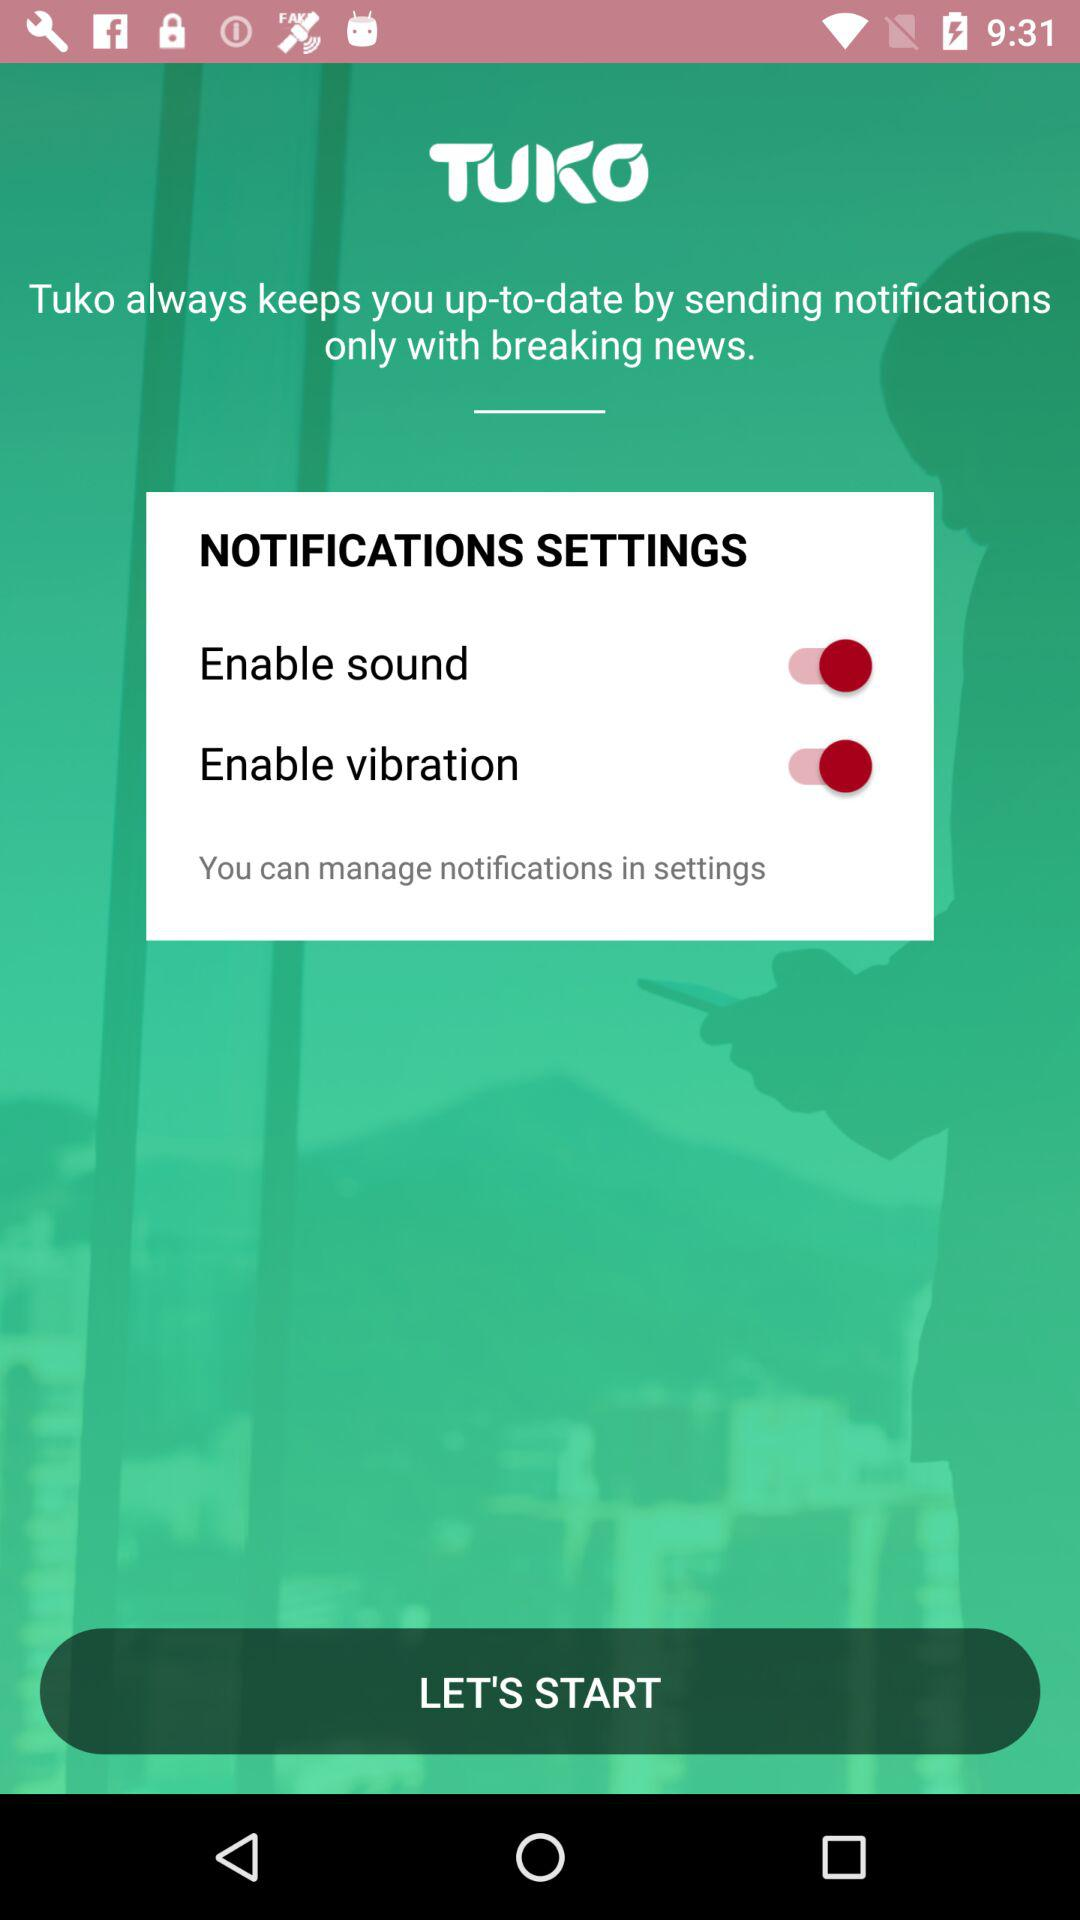What is the status of "Enable vibration"? The status of "Enable vibration" is "on". 